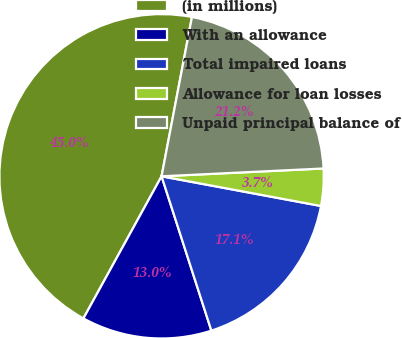<chart> <loc_0><loc_0><loc_500><loc_500><pie_chart><fcel>(in millions)<fcel>With an allowance<fcel>Total impaired loans<fcel>Allowance for loan losses<fcel>Unpaid principal balance of<nl><fcel>45.0%<fcel>12.97%<fcel>17.1%<fcel>3.7%<fcel>21.23%<nl></chart> 